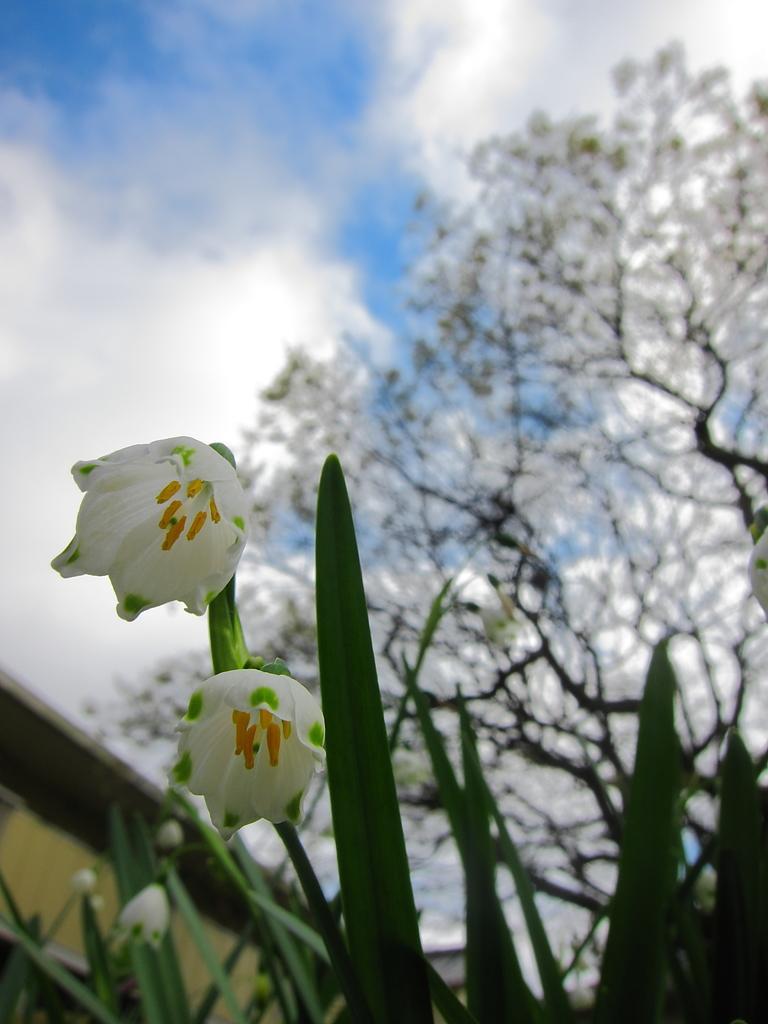Please provide a concise description of this image. Here we can see flowers and leaves. In the background we can see trees and sky with clouds. 